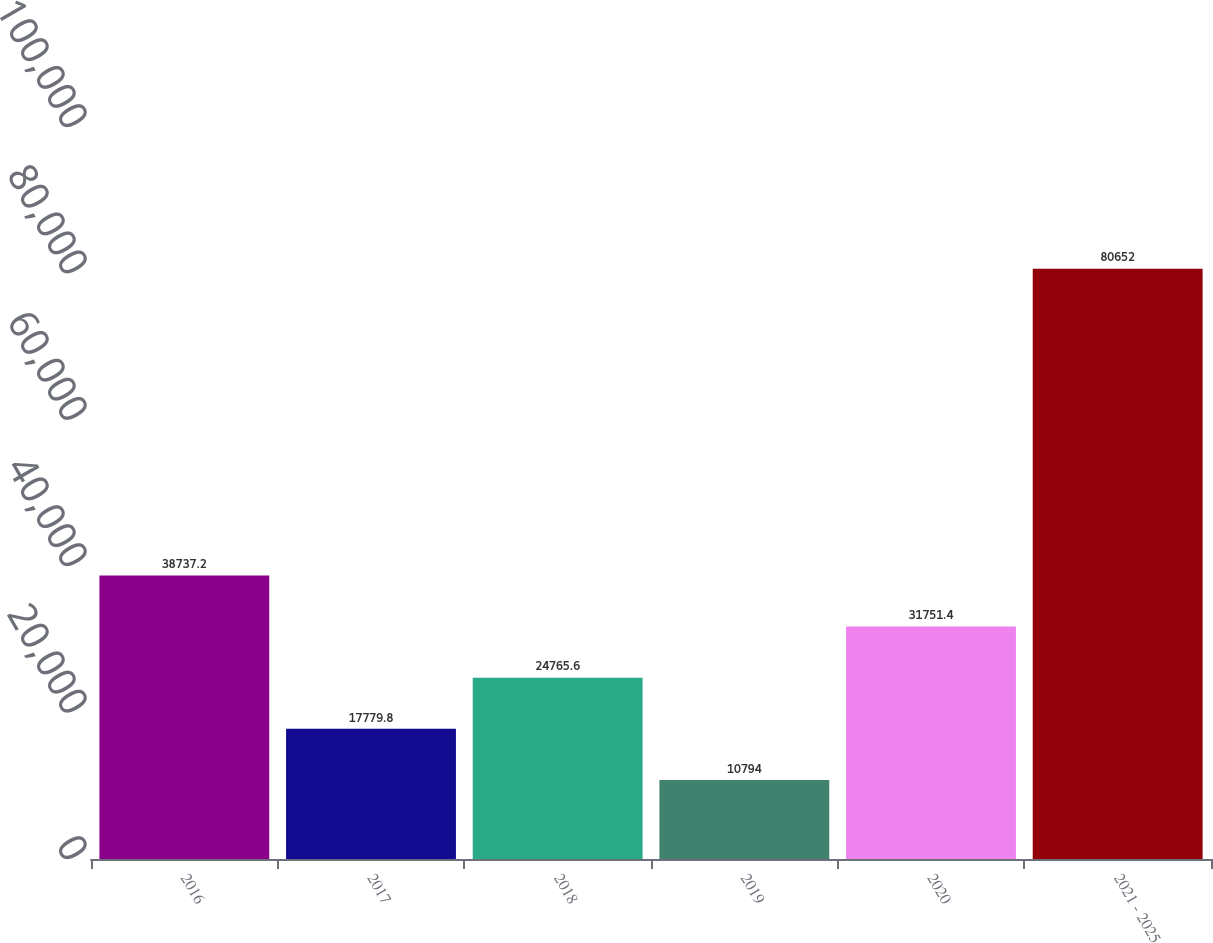<chart> <loc_0><loc_0><loc_500><loc_500><bar_chart><fcel>2016<fcel>2017<fcel>2018<fcel>2019<fcel>2020<fcel>2021 - 2025<nl><fcel>38737.2<fcel>17779.8<fcel>24765.6<fcel>10794<fcel>31751.4<fcel>80652<nl></chart> 